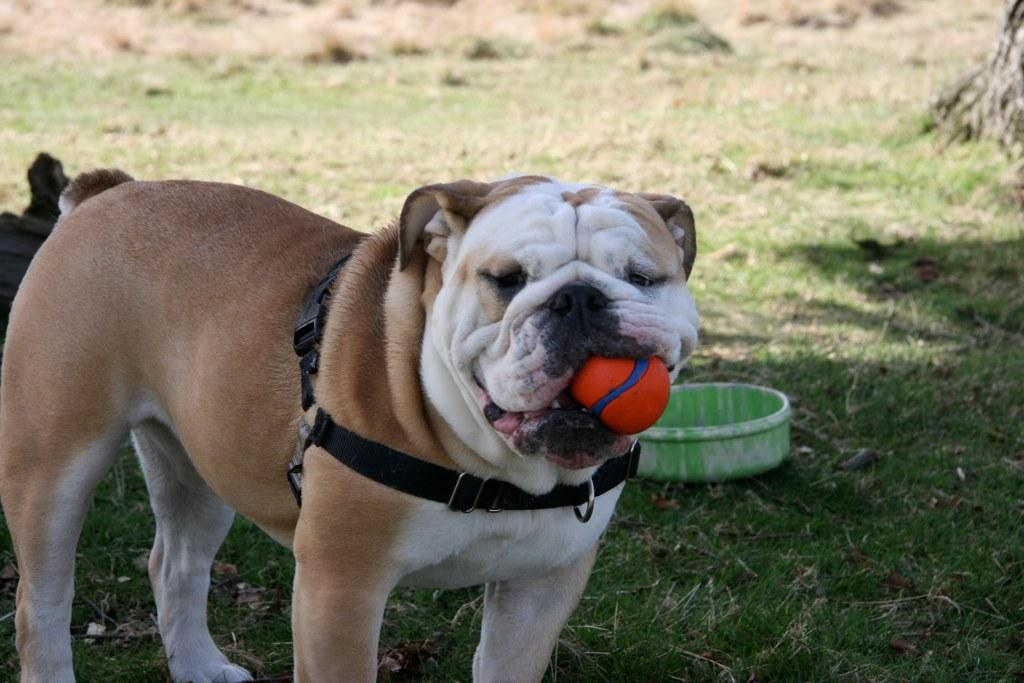What type of animal is in the image? There is a white and brown color bulldog in the image. How is the bulldog positioned in the image? The bulldog is standing in the front. What is the bulldog holding in its mouth? The bulldog is holding a ball in its mouth. What can be seen on the ground in the image? There is a green color dish vessel on the ground in the image. Where is the actor sitting in the image? There is no actor present in the image; it features a bulldog holding a ball. What type of nest can be seen in the image? There is no nest present in the image; it features a bulldog holding a ball and a green color dish vessel on the ground. 